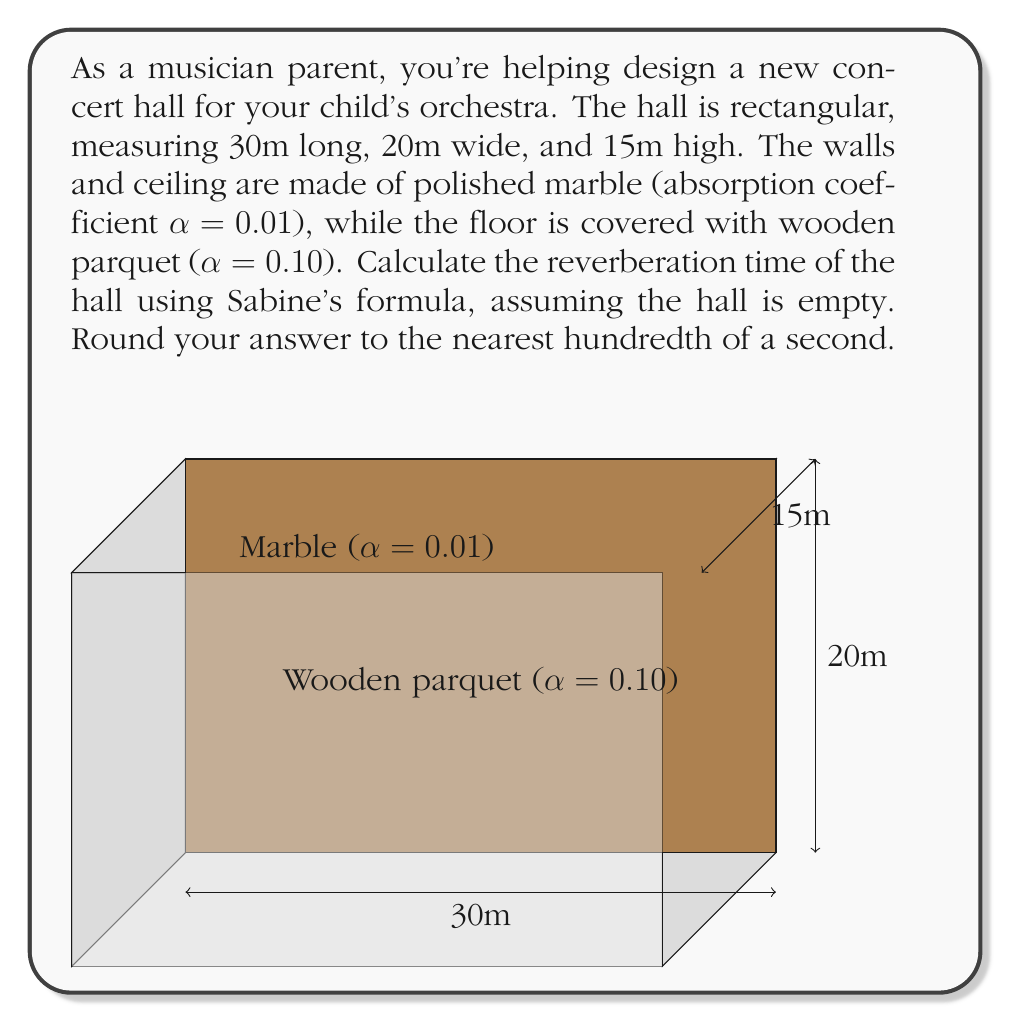Provide a solution to this math problem. To calculate the reverberation time, we'll use Sabine's formula:

$$T = \frac{0.161V}{\sum_{i=1}^n S_i\alpha_i}$$

Where:
- $T$ is the reverberation time in seconds
- $V$ is the volume of the room in cubic meters
- $S_i$ is the surface area of each material in square meters
- $\alpha_i$ is the absorption coefficient of each material

Step 1: Calculate the volume of the hall
$$V = 30m \times 20m \times 15m = 9000 m^3$$

Step 2: Calculate the surface areas
- Floor and ceiling: $S_1 = S_2 = 30m \times 20m = 600 m^2$ each
- Side walls: $S_3 = S_4 = 30m \times 15m = 450 m^2$ each
- Front and back walls: $S_5 = S_6 = 20m \times 15m = 300 m^2$ each

Step 3: Calculate $\sum_{i=1}^n S_i\alpha_i$
- Marble surfaces (walls and ceiling): $(600 + 450 + 450 + 300 + 300) \times 0.01 = 21 m^2$
- Wooden floor: $600 \times 0.10 = 60 m^2$
- Total: $21 + 60 = 81 m^2$

Step 4: Apply Sabine's formula
$$T = \frac{0.161 \times 9000}{81} = 17.90 \text{ seconds}$$

Step 5: Round to the nearest hundredth
$$T \approx 17.90 \text{ seconds}$$
Answer: 17.90 seconds 